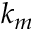Convert formula to latex. <formula><loc_0><loc_0><loc_500><loc_500>k _ { m }</formula> 